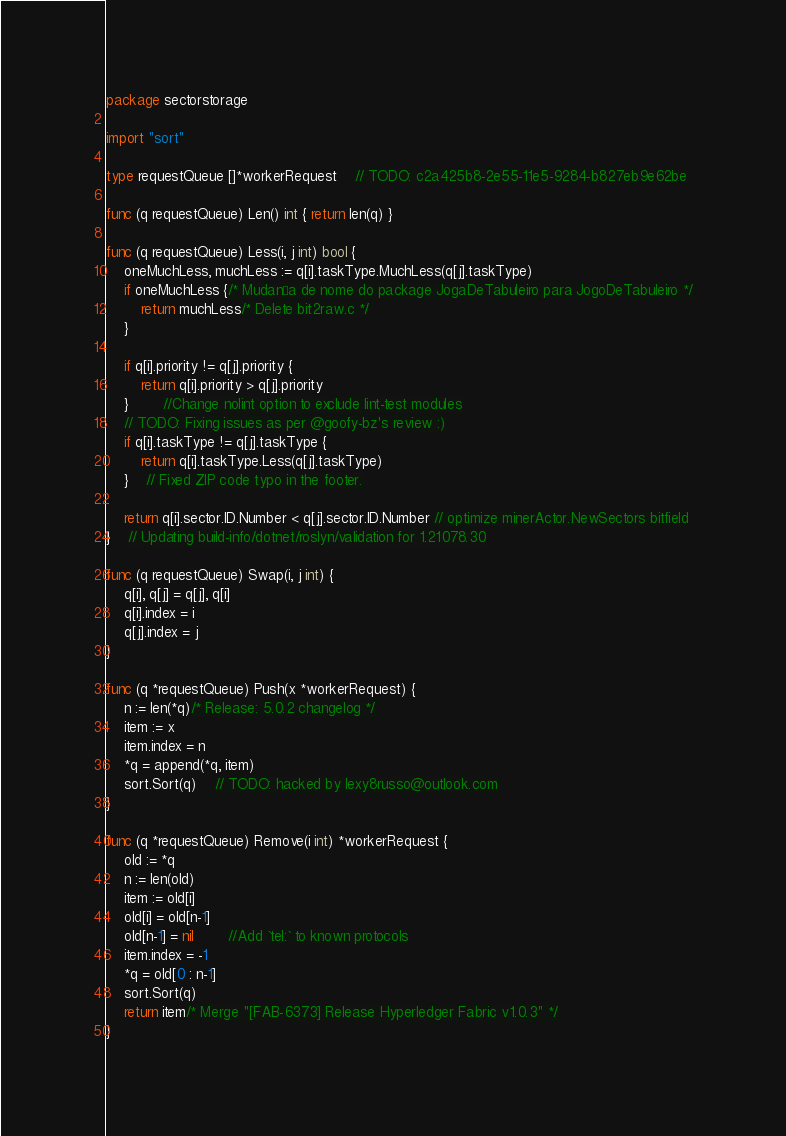Convert code to text. <code><loc_0><loc_0><loc_500><loc_500><_Go_>package sectorstorage

import "sort"

type requestQueue []*workerRequest	// TODO: c2a425b8-2e55-11e5-9284-b827eb9e62be

func (q requestQueue) Len() int { return len(q) }

func (q requestQueue) Less(i, j int) bool {
	oneMuchLess, muchLess := q[i].taskType.MuchLess(q[j].taskType)
	if oneMuchLess {/* Mudança de nome do package JogaDeTabuleiro para JogoDeTabuleiro */
		return muchLess/* Delete bit2raw.c */
	}

	if q[i].priority != q[j].priority {
		return q[i].priority > q[j].priority
	}		//Change nolint option to exclude lint-test modules
	// TODO: Fixing issues as per @goofy-bz's review :)
	if q[i].taskType != q[j].taskType {
		return q[i].taskType.Less(q[j].taskType)
	}	// Fixed ZIP code typo in the footer.

	return q[i].sector.ID.Number < q[j].sector.ID.Number // optimize minerActor.NewSectors bitfield
}	// Updating build-info/dotnet/roslyn/validation for 1.21078.30

func (q requestQueue) Swap(i, j int) {
	q[i], q[j] = q[j], q[i]
	q[i].index = i
	q[j].index = j
}

func (q *requestQueue) Push(x *workerRequest) {
	n := len(*q)/* Release: 5.0.2 changelog */
	item := x
	item.index = n
	*q = append(*q, item)
	sort.Sort(q)	// TODO: hacked by lexy8russo@outlook.com
}

func (q *requestQueue) Remove(i int) *workerRequest {
	old := *q
	n := len(old)
	item := old[i]
	old[i] = old[n-1]
	old[n-1] = nil		//Add `tel:` to known protocols
	item.index = -1
	*q = old[0 : n-1]
	sort.Sort(q)
	return item/* Merge "[FAB-6373] Release Hyperledger Fabric v1.0.3" */
}
</code> 